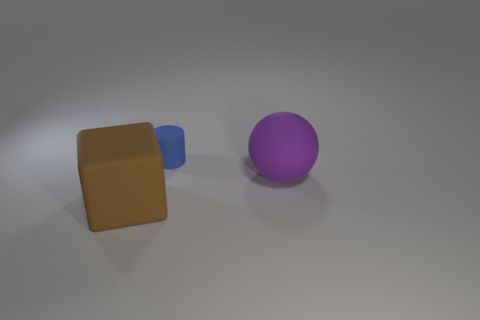Is there any other thing that has the same size as the blue rubber object?
Keep it short and to the point. No. There is a big brown object; does it have the same shape as the large thing that is behind the big brown block?
Provide a short and direct response. No. How many objects are either matte objects that are in front of the big purple ball or big things that are right of the brown cube?
Provide a short and direct response. 2. What is the brown object made of?
Your response must be concise. Rubber. How many other objects are the same size as the blue rubber cylinder?
Offer a very short reply. 0. There is a thing behind the purple matte ball; what size is it?
Ensure brevity in your answer.  Small. What material is the large brown thing that is in front of the large object behind the large thing to the left of the tiny blue cylinder?
Your answer should be very brief. Rubber. Is the shape of the blue object the same as the big brown thing?
Your response must be concise. No. What number of shiny things are either large blocks or big brown spheres?
Provide a short and direct response. 0. How many small red blocks are there?
Your answer should be compact. 0. 